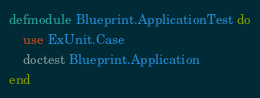<code> <loc_0><loc_0><loc_500><loc_500><_Elixir_>defmodule Blueprint.ApplicationTest do
    use ExUnit.Case
    doctest Blueprint.Application
end
</code> 